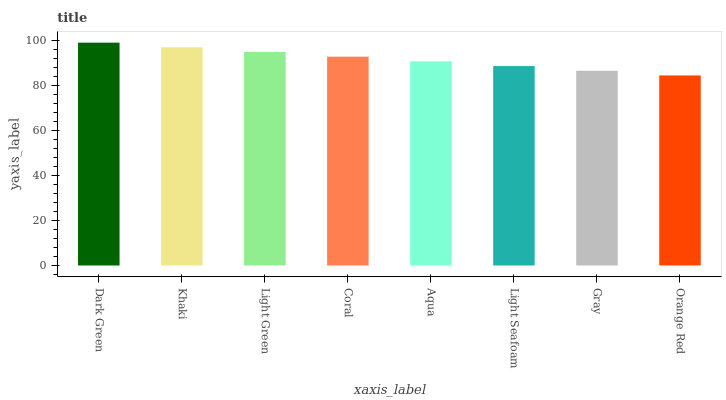Is Orange Red the minimum?
Answer yes or no. Yes. Is Dark Green the maximum?
Answer yes or no. Yes. Is Khaki the minimum?
Answer yes or no. No. Is Khaki the maximum?
Answer yes or no. No. Is Dark Green greater than Khaki?
Answer yes or no. Yes. Is Khaki less than Dark Green?
Answer yes or no. Yes. Is Khaki greater than Dark Green?
Answer yes or no. No. Is Dark Green less than Khaki?
Answer yes or no. No. Is Coral the high median?
Answer yes or no. Yes. Is Aqua the low median?
Answer yes or no. Yes. Is Light Green the high median?
Answer yes or no. No. Is Khaki the low median?
Answer yes or no. No. 